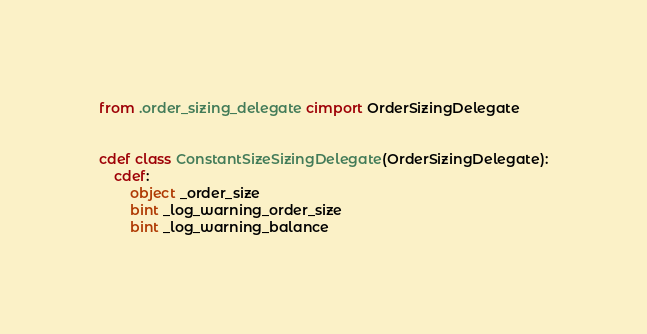Convert code to text. <code><loc_0><loc_0><loc_500><loc_500><_Cython_>from .order_sizing_delegate cimport OrderSizingDelegate


cdef class ConstantSizeSizingDelegate(OrderSizingDelegate):
    cdef:
        object _order_size
        bint _log_warning_order_size
        bint _log_warning_balance
</code> 